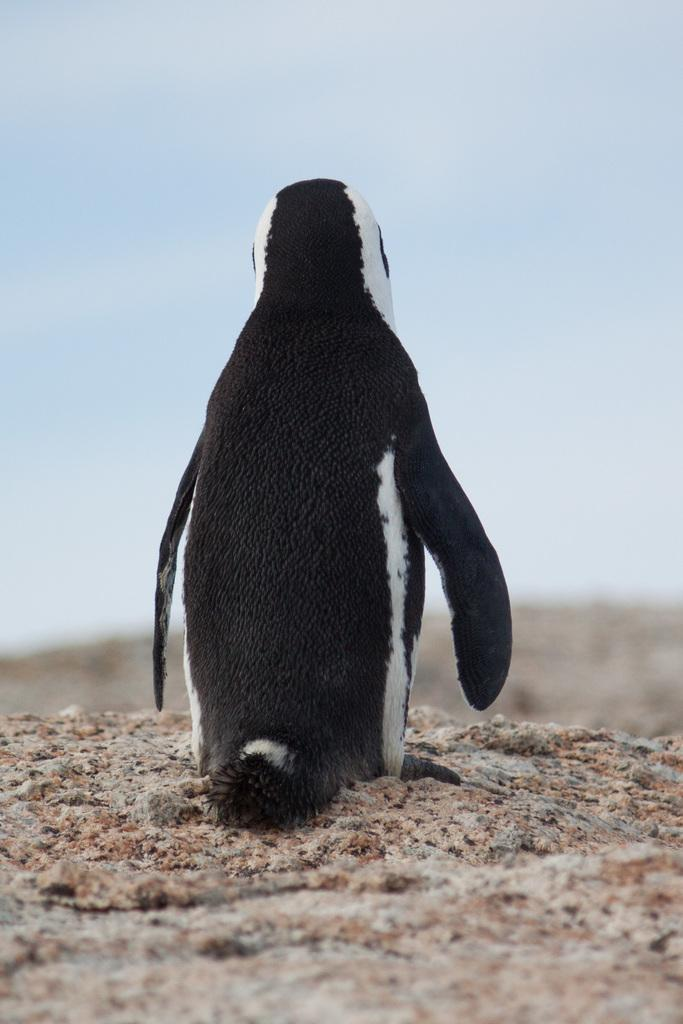What animal is present on the ground in the image? There is a penguin on the ground in the image. Can you describe the background of the image? The background is blurred in the image. What part of the natural environment is visible in the image? The sky is visible in the image. What rhythm is the queen playing in the image? There is no queen or any musical instruments present in the image, so it is not possible to determine what rhythm might be played. 